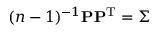<formula> <loc_0><loc_0><loc_500><loc_500>( n - 1 ) ^ { - 1 } P P ^ { T } = \Sigma</formula> 